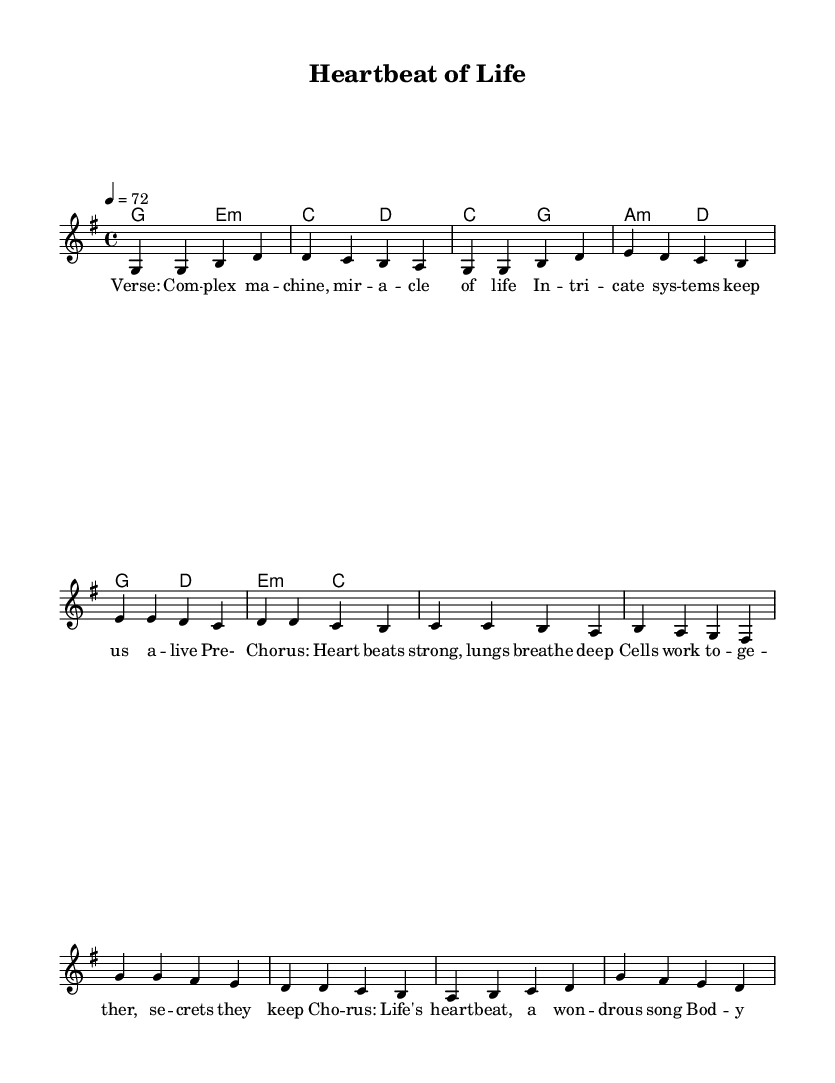What is the key signature of this music? The key signature is G major, which has one sharp (F#). This can be identified by looking at the key signature placement at the beginning of the staff.
Answer: G major What is the time signature of this piece? The time signature is four-four, indicated by the "4/4" notation at the beginning of the sheet music. This means there are four beats in each measure, and the quarter note gets one beat.
Answer: 4/4 What is the tempo marking for this piece? The tempo marking is 72 beats per minute, noted by the "4 = 72" at the beginning, indicating that the quarter note equals 72 beats per minute.
Answer: 72 How many measures are in the verse? The verse consists of four measures, which can be counted from the beginning of the verse section until it transitions to the pre-chorus.
Answer: 4 What chord follows the first measure of the verse? The chord following the first measure of the verse is E minor, as indicated in the chord progression under the melody for that section.
Answer: E minor What is the theme of the chorus? The theme of the chorus revolves around life being a wonderful song, emphasizing the connection of body and soul. This can be inferred from the lyrics presented in the chorus section.
Answer: Life's heartbeat How does the pre-chorus relate to the verse? The pre-chorus builds upon the verse by emphasizing the strength and unity of the body's systems, which adds depth to the theme introduced in the verse about life's complex machinery. This connection is derived from the lyrical content and progression in the music.
Answer: Strength and unity 